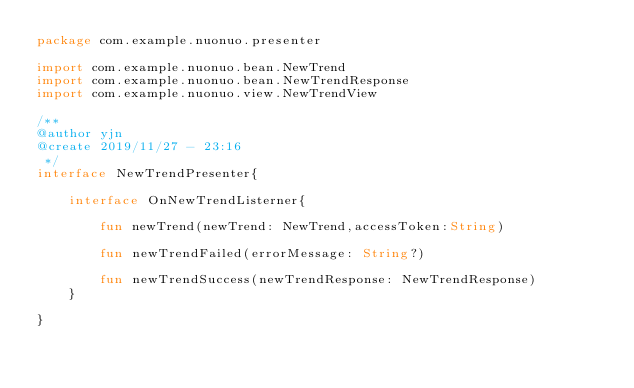Convert code to text. <code><loc_0><loc_0><loc_500><loc_500><_Kotlin_>package com.example.nuonuo.presenter

import com.example.nuonuo.bean.NewTrend
import com.example.nuonuo.bean.NewTrendResponse
import com.example.nuonuo.view.NewTrendView

/**
@author yjn
@create 2019/11/27 - 23:16
 */
interface NewTrendPresenter{

    interface OnNewTrendListerner{

        fun newTrend(newTrend: NewTrend,accessToken:String)

        fun newTrendFailed(errorMessage: String?)

        fun newTrendSuccess(newTrendResponse: NewTrendResponse)
    }

}</code> 